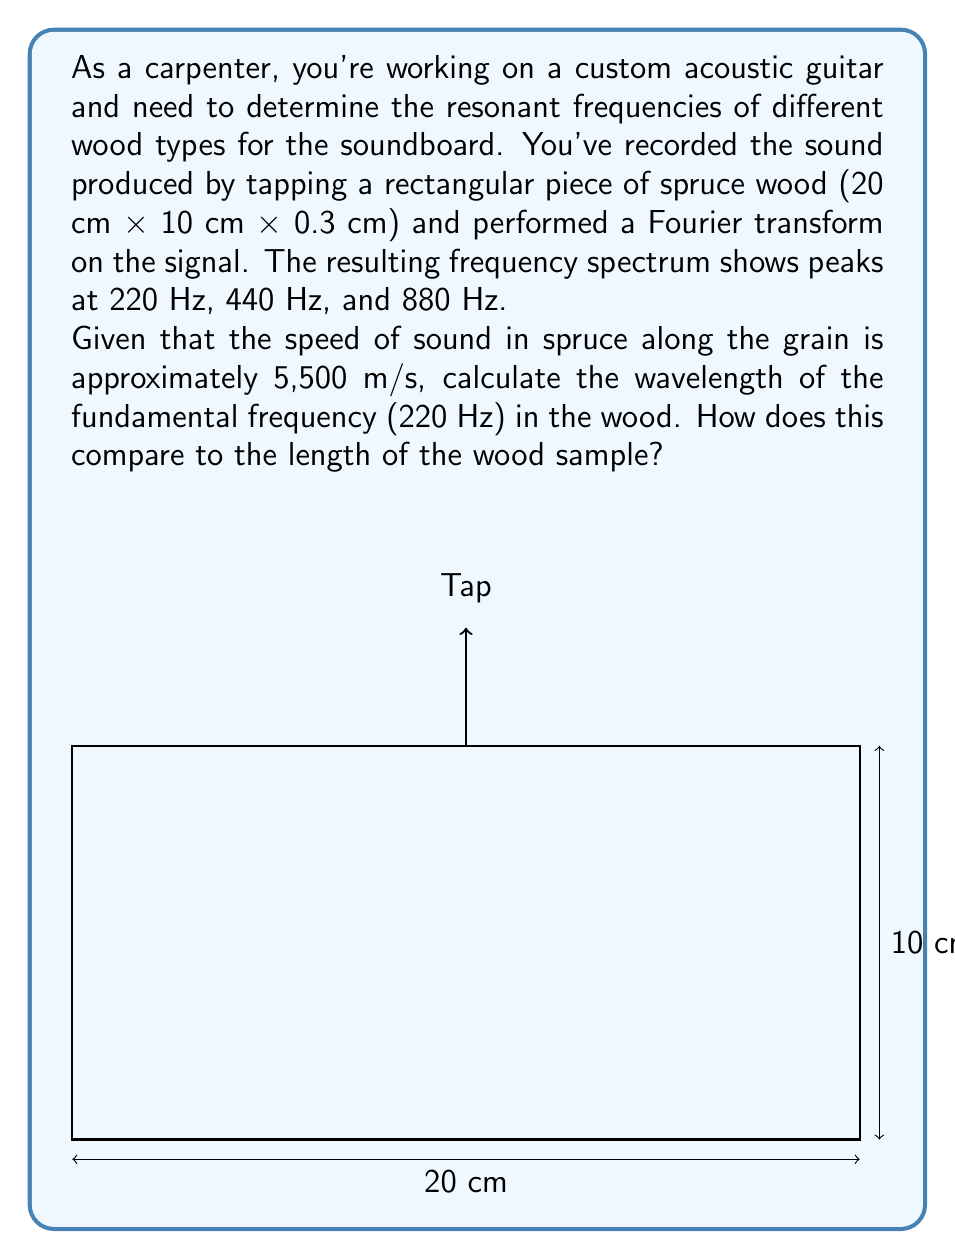Give your solution to this math problem. Let's approach this step-by-step:

1) The fundamental frequency is given as 220 Hz. We need to find its wavelength in the spruce wood.

2) The relationship between wavelength ($\lambda$), frequency ($f$), and wave speed ($v$) is given by the equation:

   $$v = f\lambda$$

3) We can rearrange this to solve for wavelength:

   $$\lambda = \frac{v}{f}$$

4) We're given:
   - Speed of sound in spruce (v) = 5,500 m/s
   - Fundamental frequency (f) = 220 Hz

5) Let's substitute these values:

   $$\lambda = \frac{5,500 \text{ m/s}}{220 \text{ Hz}} = 25 \text{ m}$$

6) To compare this to the length of the wood sample, we need to convert the sample length to meters:
   
   20 cm = 0.2 m

7) The ratio of wavelength to sample length is:

   $$\frac{\text{Wavelength}}{\text{Sample Length}} = \frac{25 \text{ m}}{0.2 \text{ m}} = 125$$

This means the wavelength of the fundamental frequency is 125 times longer than the wood sample.
Answer: $\lambda = 25 \text{ m}$, 125 times longer than the sample 